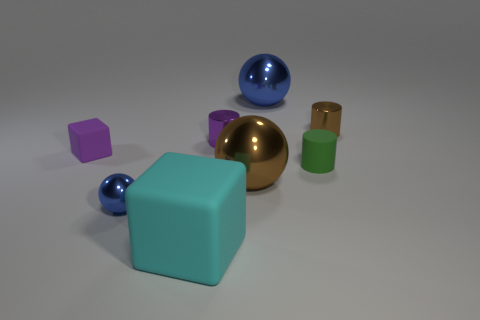Subtract all purple cylinders. How many blue balls are left? 2 Subtract all tiny brown cylinders. How many cylinders are left? 2 Add 2 large cyan matte blocks. How many objects exist? 10 Subtract all purple spheres. Subtract all cyan blocks. How many spheres are left? 3 Subtract all small blue spheres. Subtract all big blue balls. How many objects are left? 6 Add 7 small purple metal cylinders. How many small purple metal cylinders are left? 8 Add 8 tiny purple things. How many tiny purple things exist? 10 Subtract 1 purple cylinders. How many objects are left? 7 Subtract all balls. How many objects are left? 5 